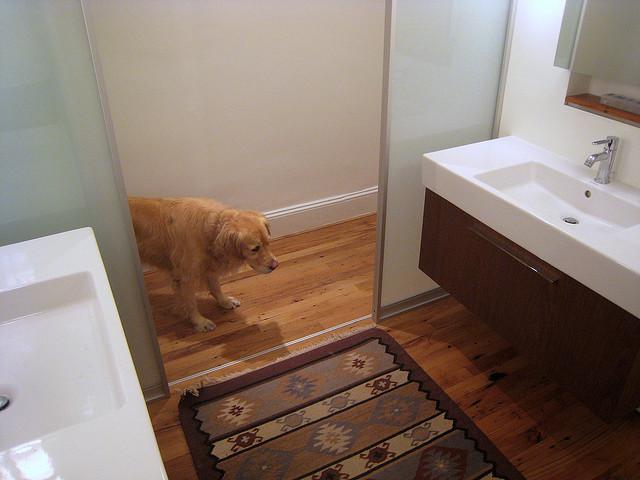What type of floor do you see?
Concise answer only. Wood. Which room is this?
Concise answer only. Bathroom. What kind of dog is that?
Give a very brief answer. Golden retriever. What kind of animal is peeking out the door?
Keep it brief. Dog. 